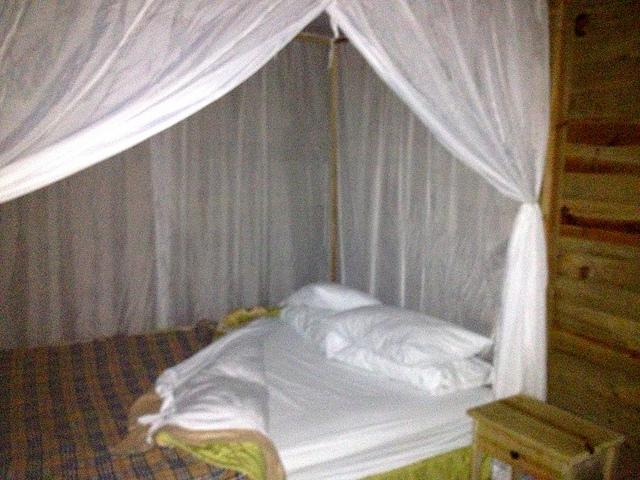How many people are holding scissors?
Give a very brief answer. 0. 